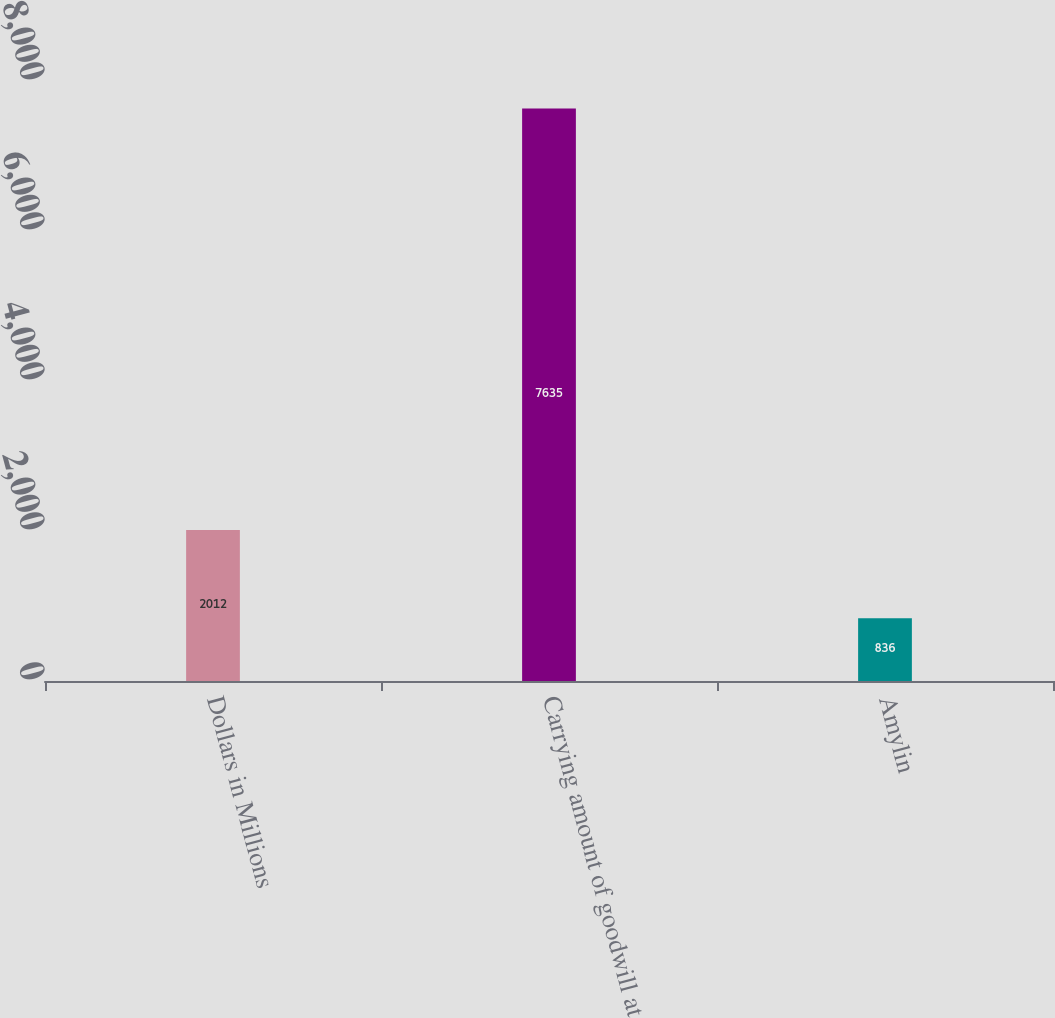<chart> <loc_0><loc_0><loc_500><loc_500><bar_chart><fcel>Dollars in Millions<fcel>Carrying amount of goodwill at<fcel>Amylin<nl><fcel>2012<fcel>7635<fcel>836<nl></chart> 